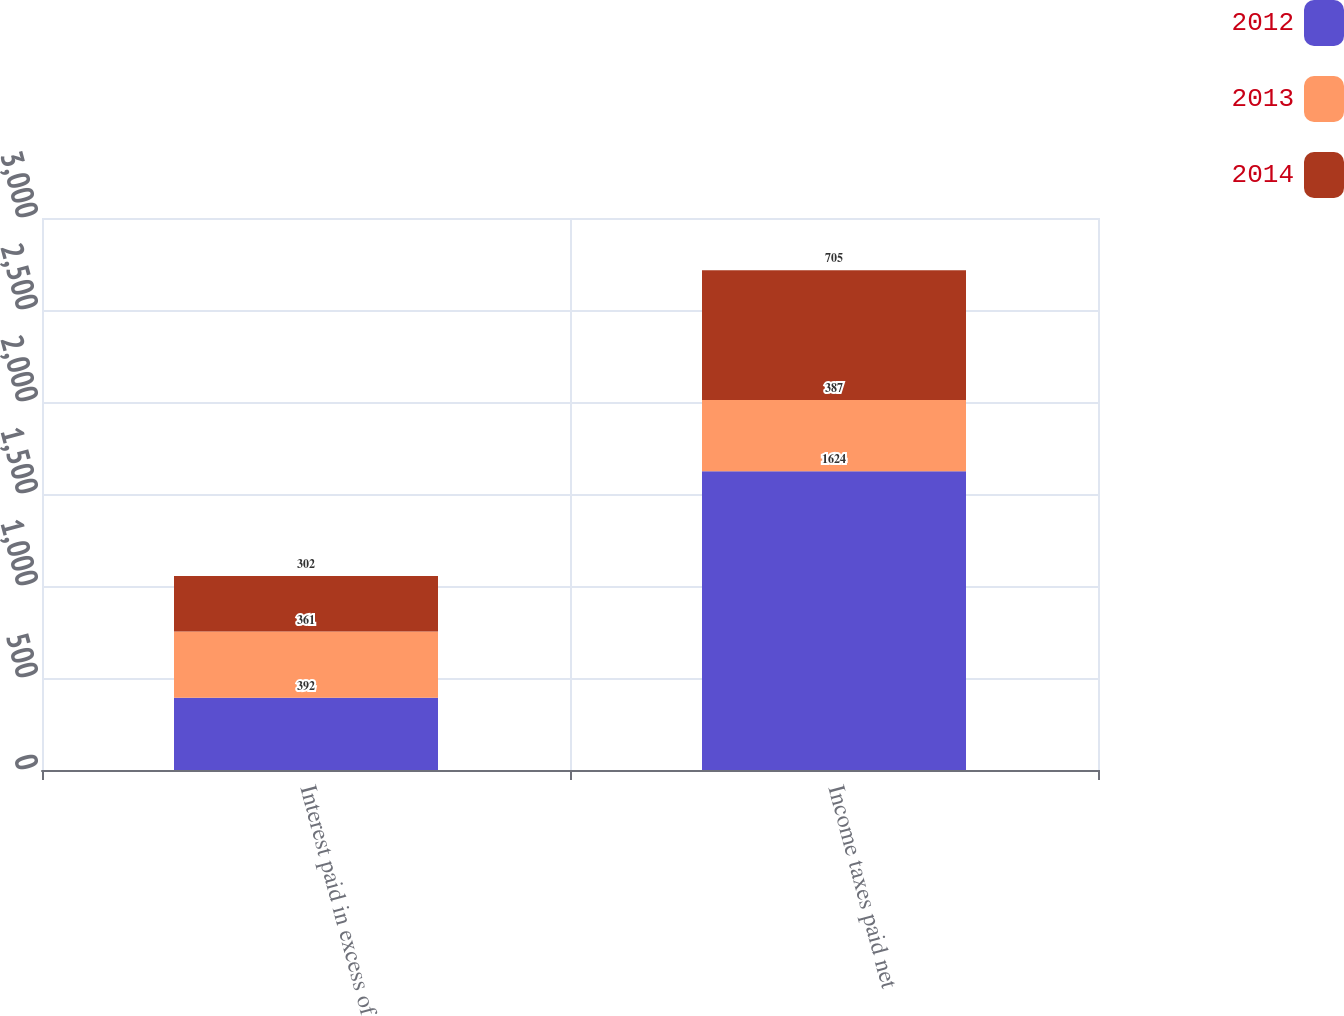Convert chart to OTSL. <chart><loc_0><loc_0><loc_500><loc_500><stacked_bar_chart><ecel><fcel>Interest paid in excess of<fcel>Income taxes paid net<nl><fcel>2012<fcel>392<fcel>1624<nl><fcel>2013<fcel>361<fcel>387<nl><fcel>2014<fcel>302<fcel>705<nl></chart> 